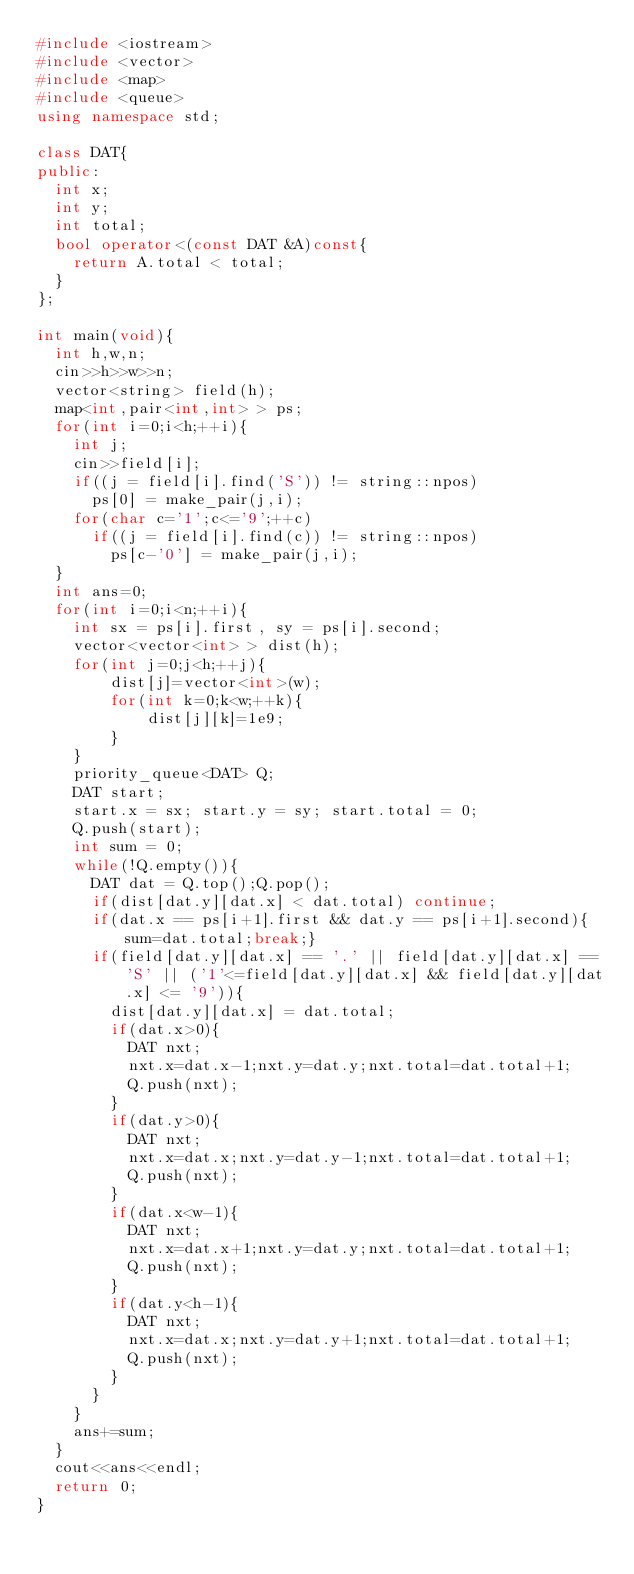Convert code to text. <code><loc_0><loc_0><loc_500><loc_500><_C++_>#include <iostream>
#include <vector>
#include <map>
#include <queue>
using namespace std;

class DAT{
public:
  int x;
  int y;
  int total;
  bool operator<(const DAT &A)const{
    return A.total < total;
  }
};

int main(void){
  int h,w,n;
  cin>>h>>w>>n;
  vector<string> field(h);
  map<int,pair<int,int> > ps;
  for(int i=0;i<h;++i){
    int j;
    cin>>field[i];
    if((j = field[i].find('S')) != string::npos)
      ps[0] = make_pair(j,i);
    for(char c='1';c<='9';++c)
      if((j = field[i].find(c)) != string::npos)
        ps[c-'0'] = make_pair(j,i);
  }
  int ans=0;
  for(int i=0;i<n;++i){
    int sx = ps[i].first, sy = ps[i].second;
    vector<vector<int> > dist(h);
    for(int j=0;j<h;++j){
    	dist[j]=vector<int>(w);
    	for(int k=0;k<w;++k){
    		dist[j][k]=1e9;
    	}
    }
    priority_queue<DAT> Q;
    DAT start;
    start.x = sx; start.y = sy; start.total = 0;
    Q.push(start);
    int sum = 0;
    while(!Q.empty()){
      DAT dat = Q.top();Q.pop();
      if(dist[dat.y][dat.x] < dat.total) continue;
      if(dat.x == ps[i+1].first && dat.y == ps[i+1].second){sum=dat.total;break;}
      if(field[dat.y][dat.x] == '.' || field[dat.y][dat.x] == 'S' || ('1'<=field[dat.y][dat.x] && field[dat.y][dat.x] <= '9')){
        dist[dat.y][dat.x] = dat.total;
        if(dat.x>0){
          DAT nxt;
          nxt.x=dat.x-1;nxt.y=dat.y;nxt.total=dat.total+1;
          Q.push(nxt);
        }
        if(dat.y>0){
          DAT nxt;
          nxt.x=dat.x;nxt.y=dat.y-1;nxt.total=dat.total+1;
          Q.push(nxt);
        }
        if(dat.x<w-1){
          DAT nxt;
          nxt.x=dat.x+1;nxt.y=dat.y;nxt.total=dat.total+1;
          Q.push(nxt);
        }
        if(dat.y<h-1){
          DAT nxt;
          nxt.x=dat.x;nxt.y=dat.y+1;nxt.total=dat.total+1;
          Q.push(nxt);
        }
      }
    }
    ans+=sum;
  }
  cout<<ans<<endl;
  return 0;
}</code> 